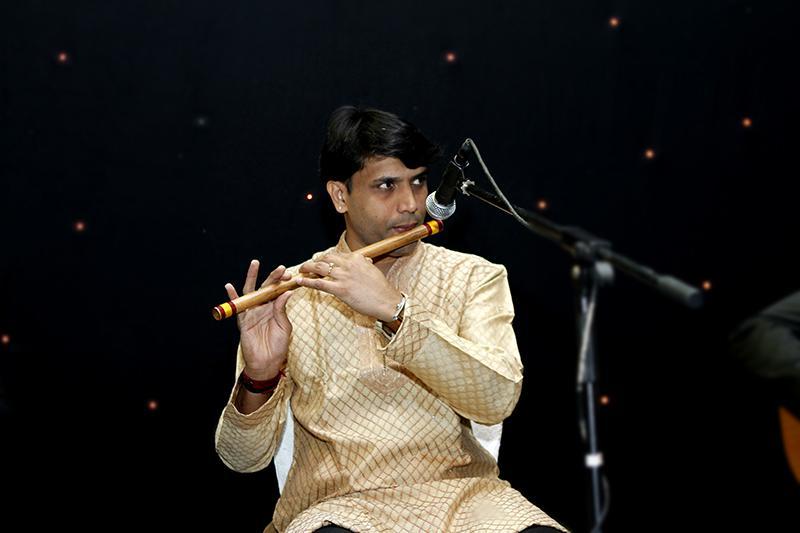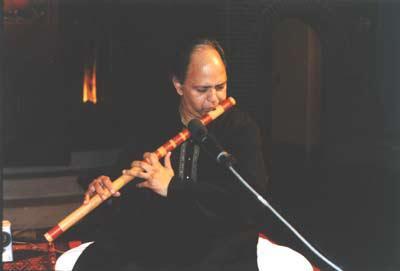The first image is the image on the left, the second image is the image on the right. For the images shown, is this caption "a man in a button down shirt with a striped banner on his shoulder is playing a wooden flute" true? Answer yes or no. No. The first image is the image on the left, the second image is the image on the right. Examine the images to the left and right. Is the description "The left image contains a man in a red long sleeved shirt playing a musical instrument." accurate? Answer yes or no. No. 